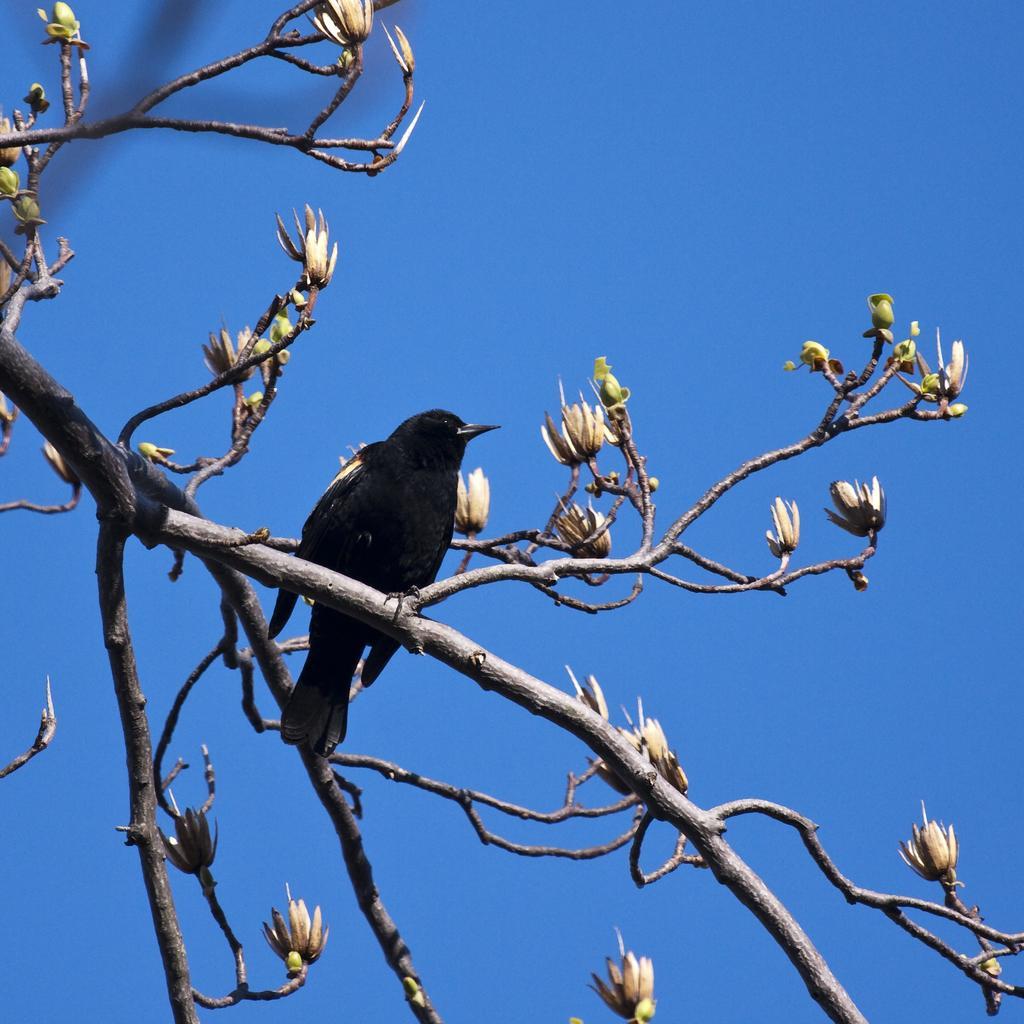Describe this image in one or two sentences. This image consists of a bird in black color. It is on the stem of a tree. And we can see some flowers. In the background, there is sky in blue color. 